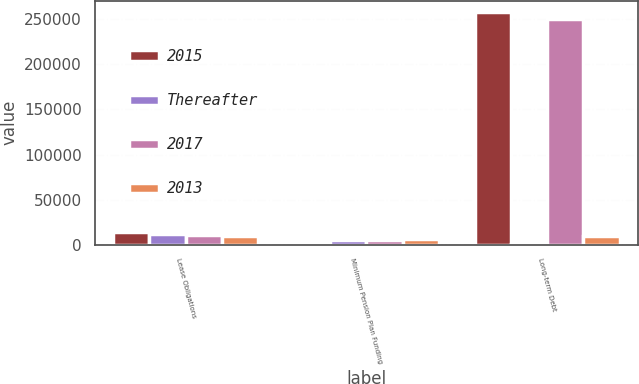<chart> <loc_0><loc_0><loc_500><loc_500><stacked_bar_chart><ecel><fcel>Lease Obligations<fcel>Minimum Pension Plan Funding<fcel>Long-term Debt<nl><fcel>2015<fcel>13688<fcel>2780<fcel>257734<nl><fcel>Thereafter<fcel>11782<fcel>5280<fcel>854<nl><fcel>2017<fcel>10904<fcel>5650<fcel>250854<nl><fcel>2013<fcel>9881<fcel>5750<fcel>9881<nl></chart> 